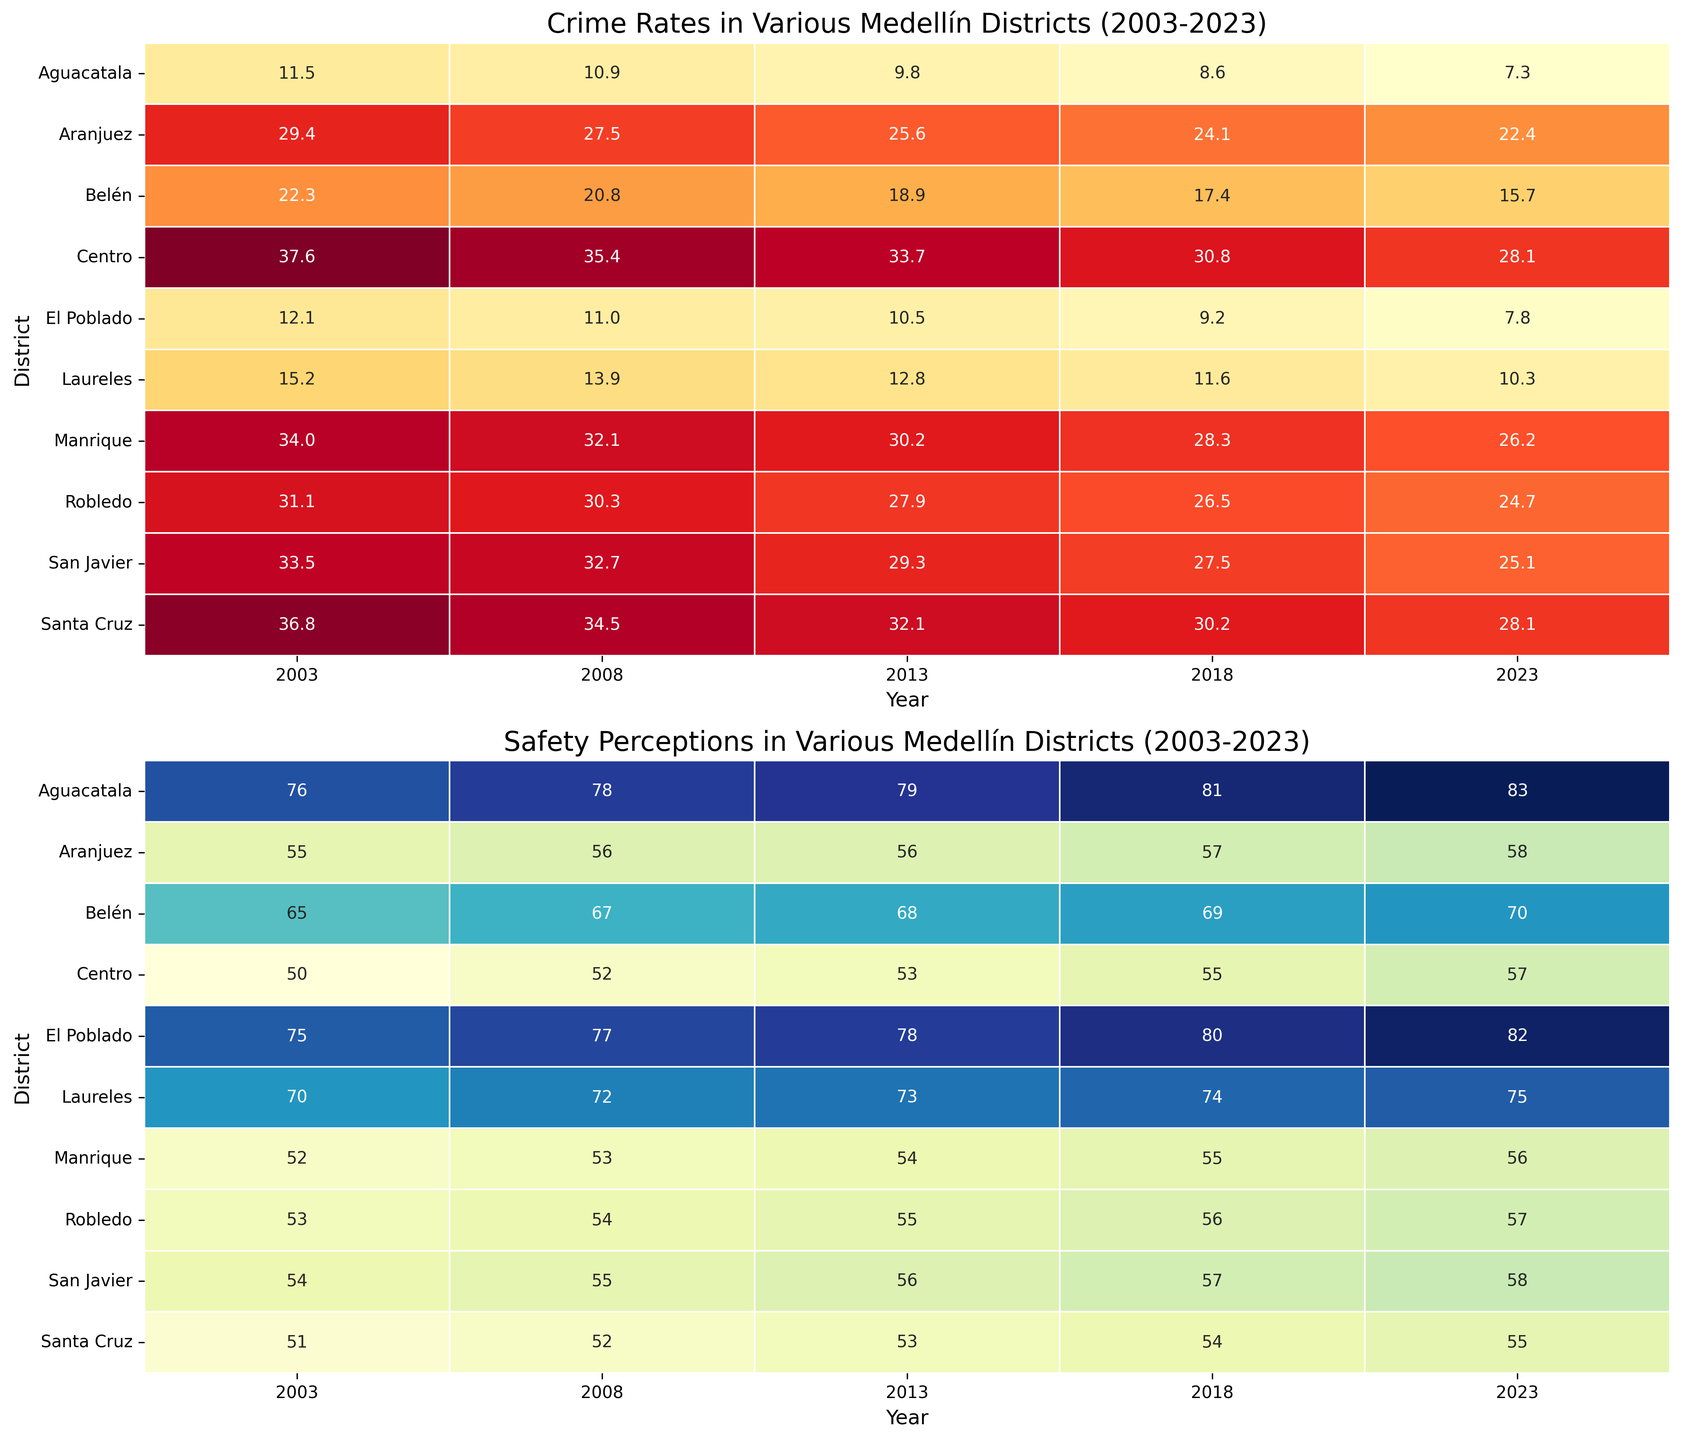What trend do you observe in the crime rate for El Poblado from 2003 to 2023? By looking at the heatmap, we can observe that the crime rate in El Poblado has steadily decreased from 12.1 in 2003 to 7.8 in 2023, showing a downward trend over the years.
Answer: Steadily decreasing Between 2003 and 2023, which district had the most significant decrease in crime rates? Comparing the values in the heatmap across the years, we can see that Aguacatala had the most significant drop in crime rates, from 11.5 in 2003 to 7.3 in 2023. This is a decrease of 4.2.
Answer: Aguacatala Which district had the highest perception of safety in 2023? By analyzing the heatmap for safety perceptions in 2023, we see that Aguacatala had the highest perception of safety, with a value of 83.
Answer: Aguacatala How do the safety perceptions in 2023 for Centro and Belén compare? In the heatmap, looking at the figures for 2023, the perception of safety for Centro is 57, while for Belén, it is 70. This indicates that Belén has a higher perception of safety compared to Centro.
Answer: Belén is higher What is the average crime rate for Laureles over the five years shown? The crime rates for Laureles are 15.2, 13.9, 12.8, 11.6, and 10.3 for 2003, 2008, 2013, 2018, and 2023, respectively. Adding these gives 63.8, and dividing by 5 gives an average crime rate of 12.76.
Answer: 12.76 In which district and year do we see the worst perception of safety? By examining the safety perception heatmap, we observe that the lowest perception of safety is in Centro in 2003, with a value of 50.
Answer: Centro in 2003 How has the crime rate in Manrique changed from 2003 to 2023? Looking at the heatmap for Manrique, we see that the crime rate was 34 in 2003 and decreased to 26.2 in 2023. This indicates a decrease of 7.8 over the 20 years.
Answer: Decreased by 7.8 Which district showed the most improvement in safety perception from 2003 to 2023? Comparing the values in the heatmap for safety perception, Aguacatala had an increase from 76 in 2003 to 83 in 2023, showing the most improvement in safety perception with a gain of 7.
Answer: Aguacatala Compare the crime rate between Aranjuez in 2003 and Santa Cruz in 2023. From the heatmap, the crime rate for Aranjuez in 2003 was 29.4, and for Santa Cruz in 2023, it was 28.1. Santa Cruz in 2023 had a slightly lower crime rate than Aranjuez in 2003.
Answer: Santa Cruz in 2023 is lower What is the median perception of safety for El Poblado across all the years shown? The safety perceptions for El Poblado are 75, 77, 78, 80, and 82. The median value, which is the middle number in an ordered list, is 78.
Answer: 78 